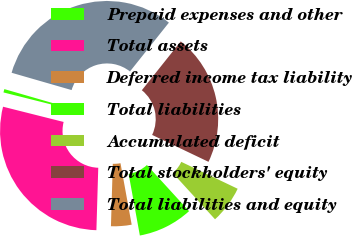Convert chart. <chart><loc_0><loc_0><loc_500><loc_500><pie_chart><fcel>Prepaid expenses and other<fcel>Total assets<fcel>Deferred income tax liability<fcel>Total liabilities<fcel>Accumulated deficit<fcel>Total stockholders' equity<fcel>Total liabilities and equity<nl><fcel>0.55%<fcel>28.45%<fcel>3.34%<fcel>8.92%<fcel>6.13%<fcel>21.38%<fcel>31.24%<nl></chart> 